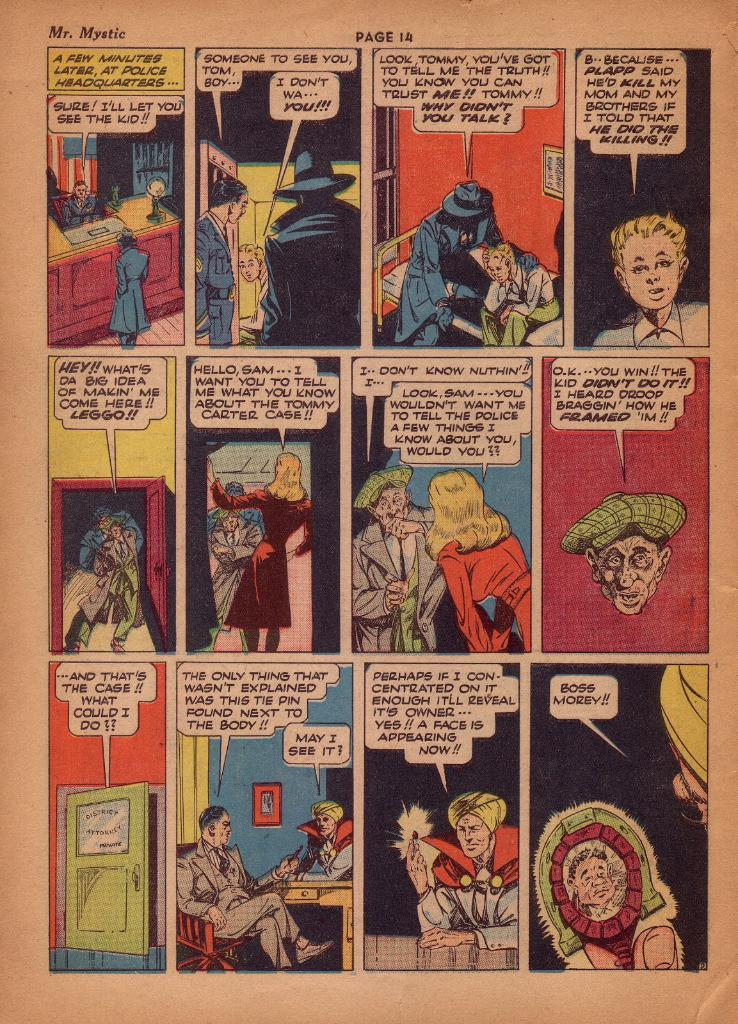Provide a one-sentence caption for the provided image. A comic book page features a character named Mr. Mystic. 